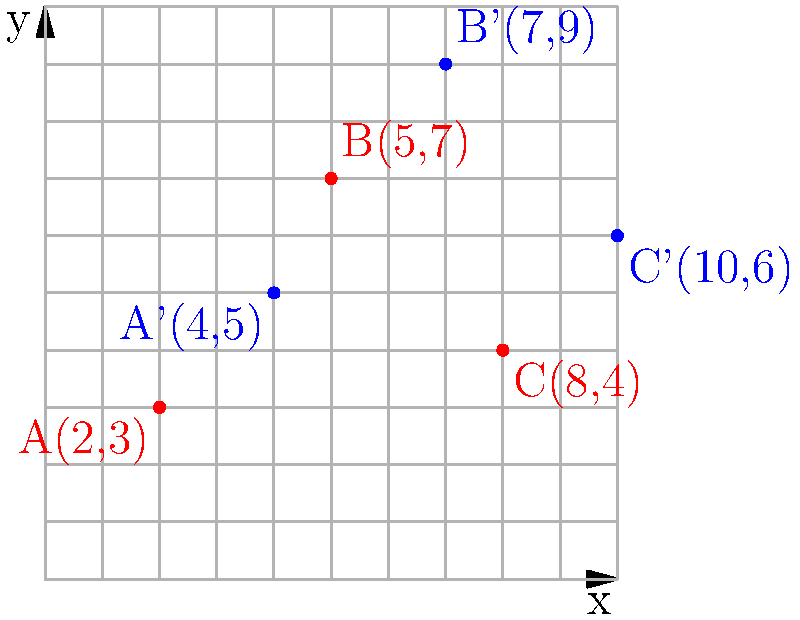As part of your environmental activism work, you're helping to map endangered species habitats in White River National Forest. The Forest Service is updating their grid system, which requires translating all habitat coordinates. If all points are translated 2 units right and 2 units up, what will be the new coordinates of a lynx den currently located at (5,7)? To solve this problem, we need to apply the given translation to the original coordinates. Here's a step-by-step explanation:

1. Identify the translation:
   - 2 units right (positive x-direction)
   - 2 units up (positive y-direction)

2. Express the translation mathematically:
   - For x-coordinate: Add 2
   - For y-coordinate: Add 2

3. Apply the translation to the given point (5,7):
   - New x-coordinate: $5 + 2 = 7$
   - New y-coordinate: $7 + 2 = 9$

4. Write the new coordinates in ordered pair notation:
   $(7,9)$

This translation can be represented as a function:
$T(x,y) = (x+2, y+2)$

In this case, $T(5,7) = (5+2, 7+2) = (7,9)$

The graph shows three original points (in red) and their translated counterparts (in blue). The point B(5,7) corresponds to B'(7,9) after the translation.
Answer: (7,9) 